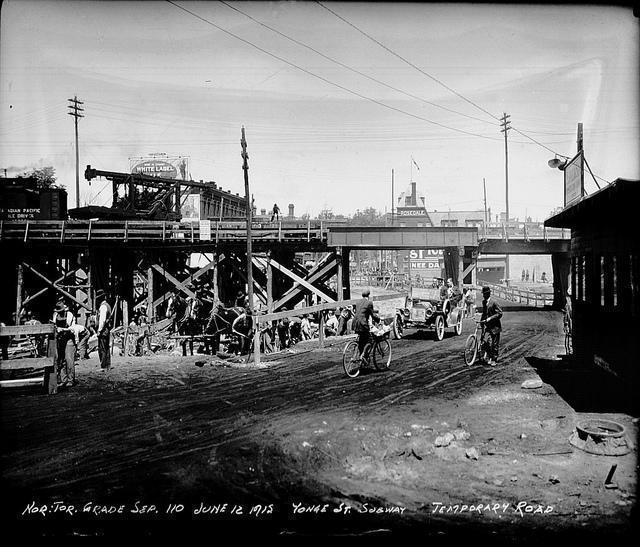What is near the car?
From the following four choices, select the correct answer to address the question.
Options: Bison, museum, bicycles, apple pie. Bicycles. 